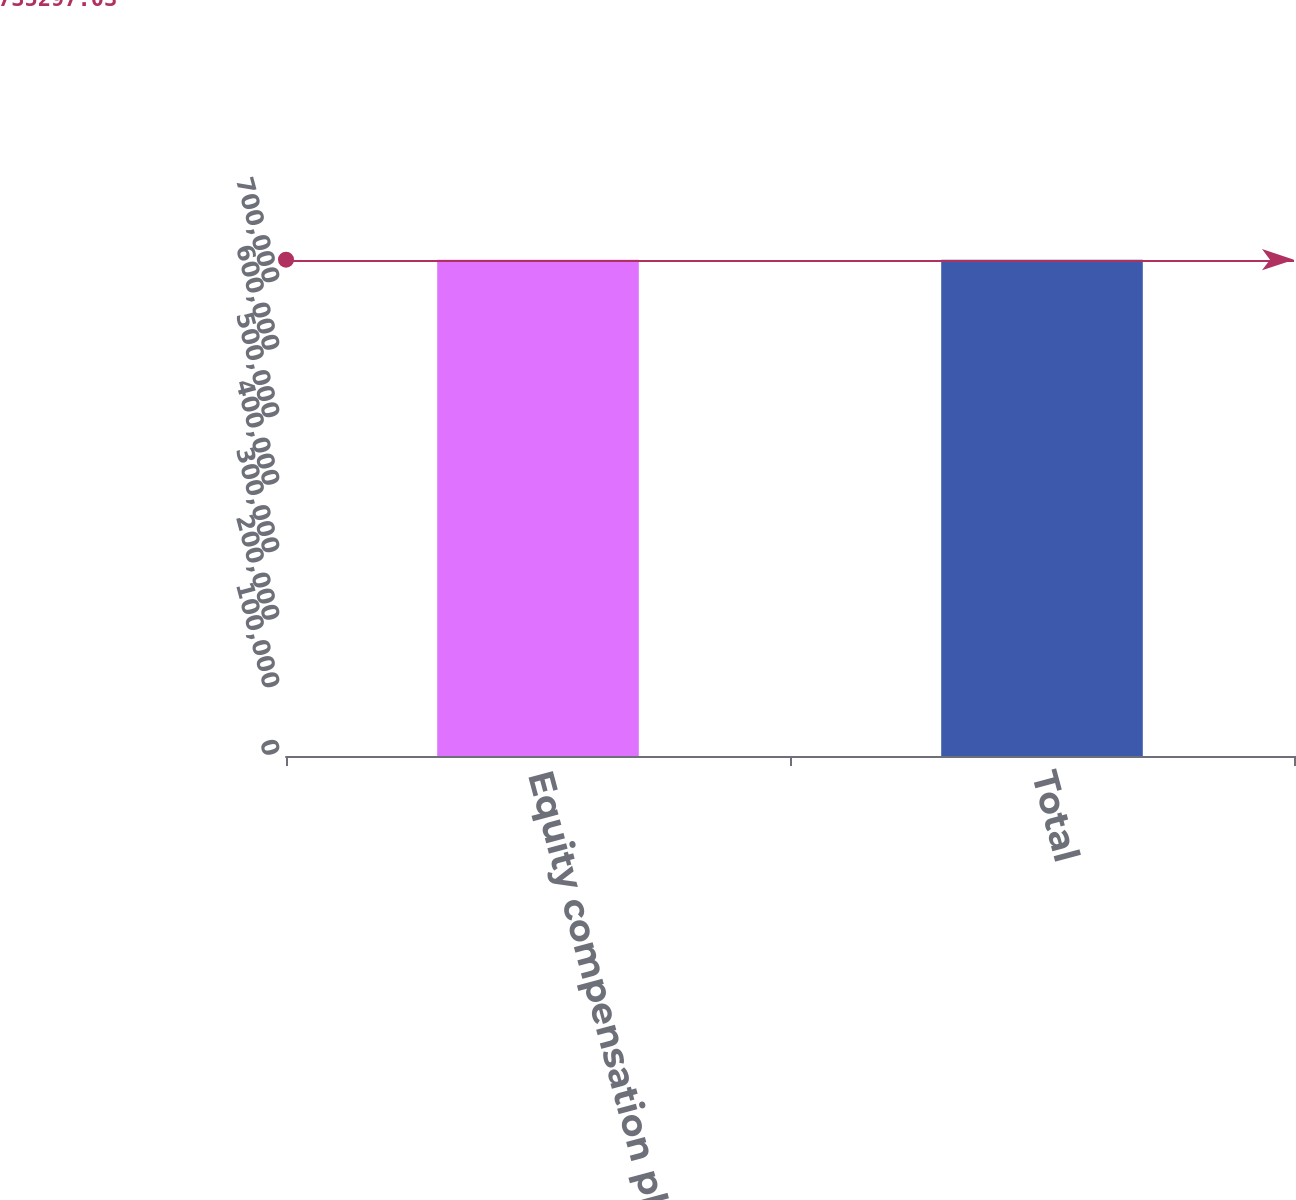<chart> <loc_0><loc_0><loc_500><loc_500><bar_chart><fcel>Equity compensation plans<fcel>Total<nl><fcel>735297<fcel>735297<nl></chart> 